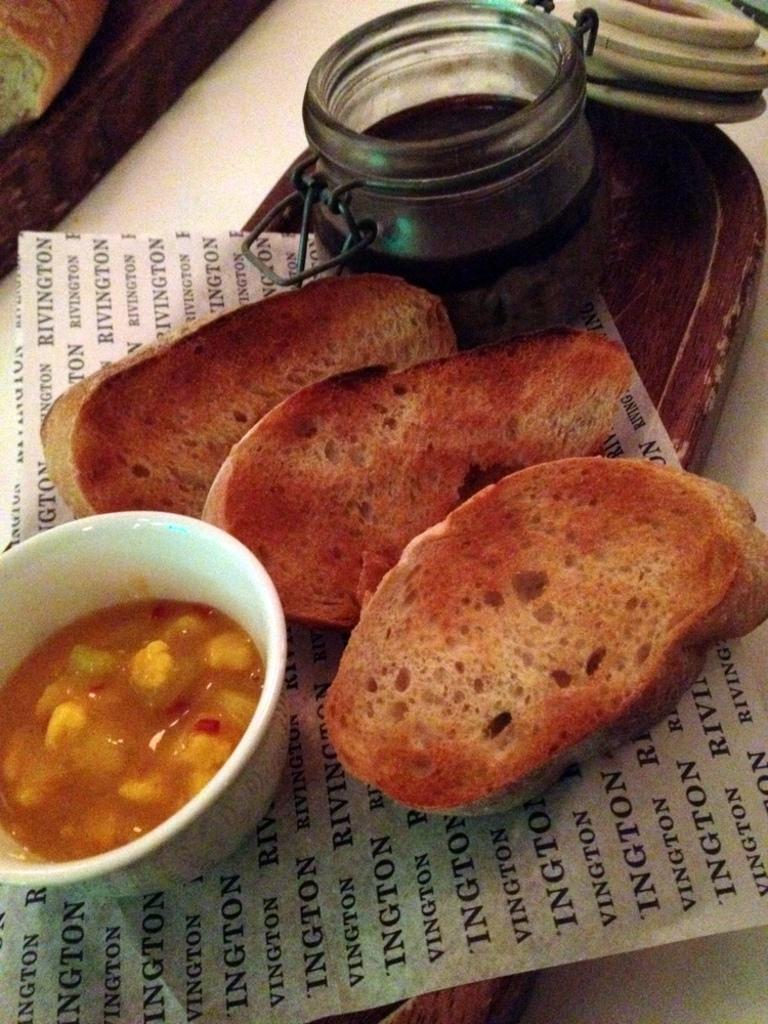What piece of furniture is present in the image? There is a table in the image. What is placed on the table? There is a plate on the table. What can be found on the plate? There are food items on the plate. Is there any additional item on the table? Yes, there is a paper on the table. Are there any trains visible on the table in the image? No, there are no trains present in the image. Is there a sink visible on the table in the image? No, there is no sink present in the image. 